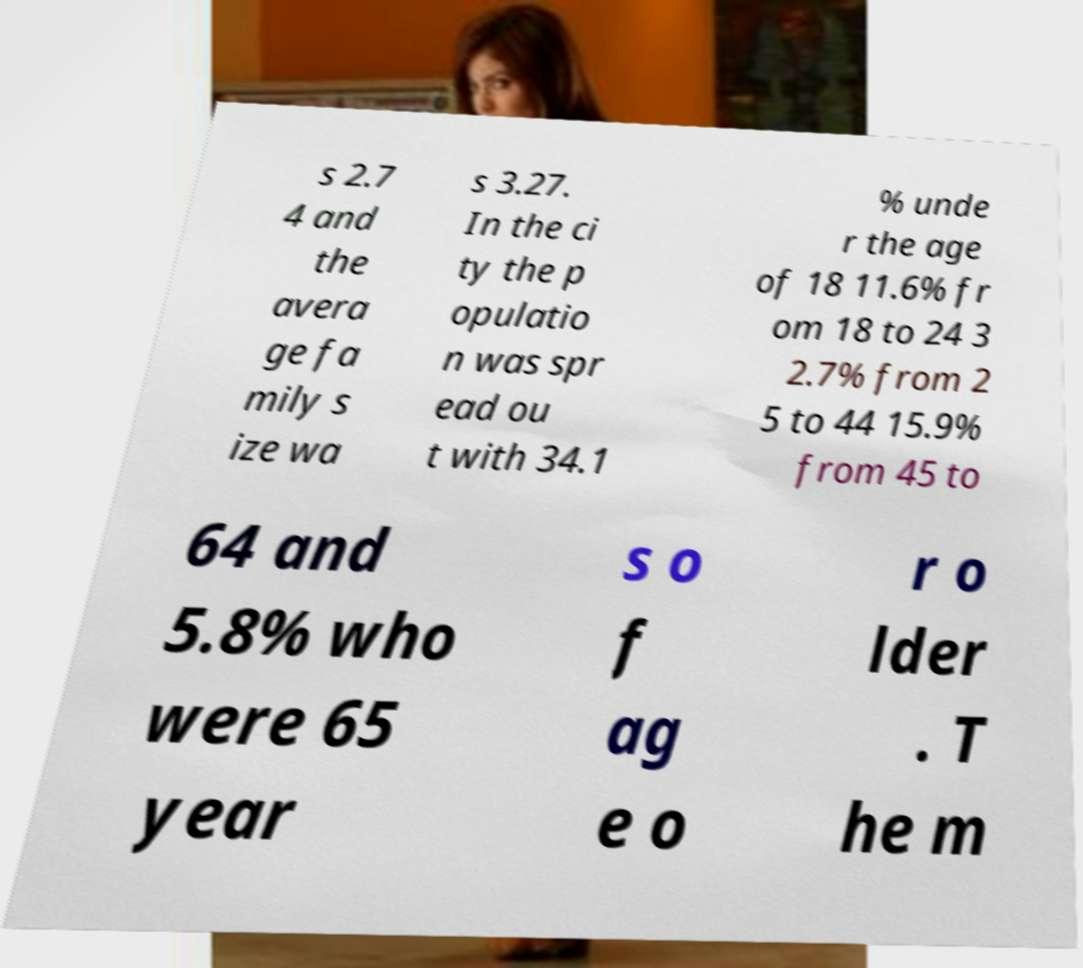Can you read and provide the text displayed in the image?This photo seems to have some interesting text. Can you extract and type it out for me? s 2.7 4 and the avera ge fa mily s ize wa s 3.27. In the ci ty the p opulatio n was spr ead ou t with 34.1 % unde r the age of 18 11.6% fr om 18 to 24 3 2.7% from 2 5 to 44 15.9% from 45 to 64 and 5.8% who were 65 year s o f ag e o r o lder . T he m 